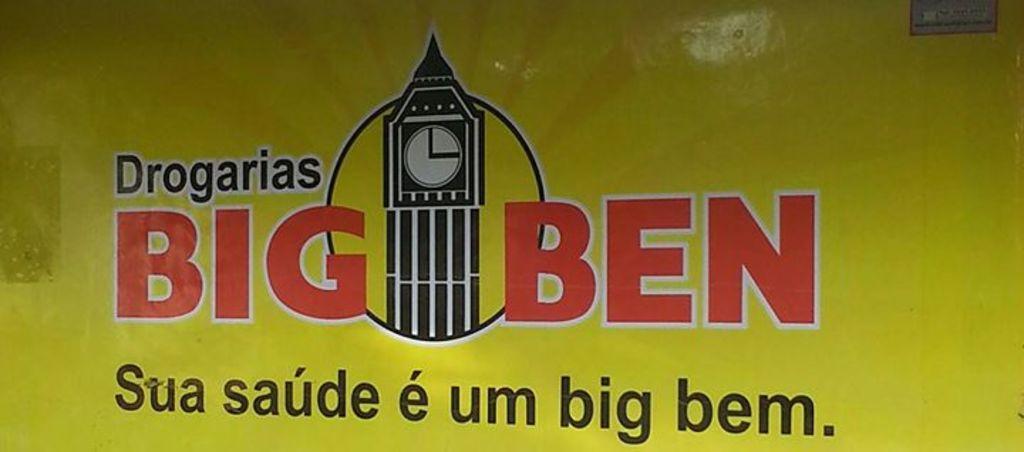In one or two sentences, can you explain what this image depicts? In this picture we can see some advertisement painting. In the center we can see the clock tower. On the top right corner we can see object. 